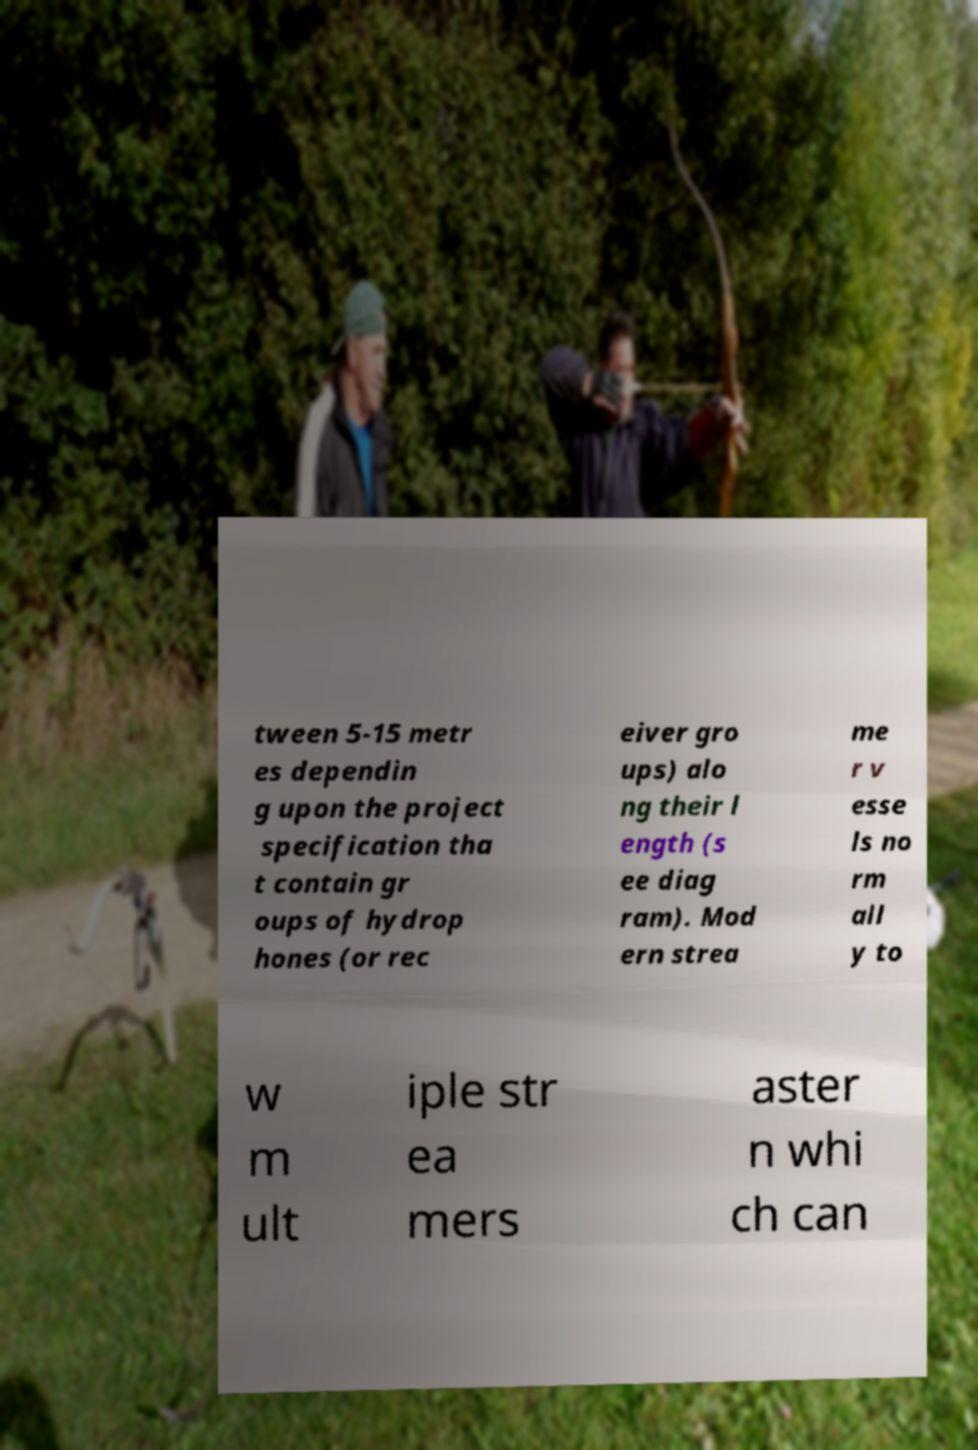I need the written content from this picture converted into text. Can you do that? tween 5-15 metr es dependin g upon the project specification tha t contain gr oups of hydrop hones (or rec eiver gro ups) alo ng their l ength (s ee diag ram). Mod ern strea me r v esse ls no rm all y to w m ult iple str ea mers aster n whi ch can 